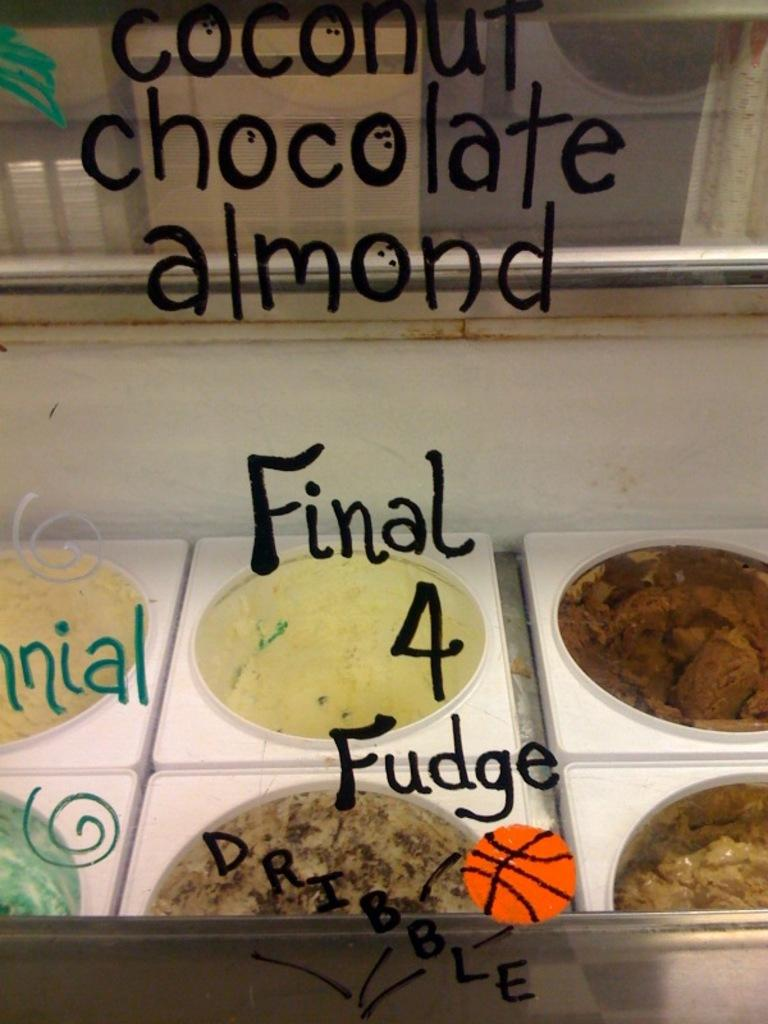What is present in the image that can hold a liquid? There is a glass in the image. What is written on the glass? Something is written on the glass. What can be seen through the glass? Ice creams are visible through the glass. What color is the surface that the glass is placed on? There is a white color surface in the image. How many straws are used to blow bubbles in the image? There are no straws or bubbles present in the image. 